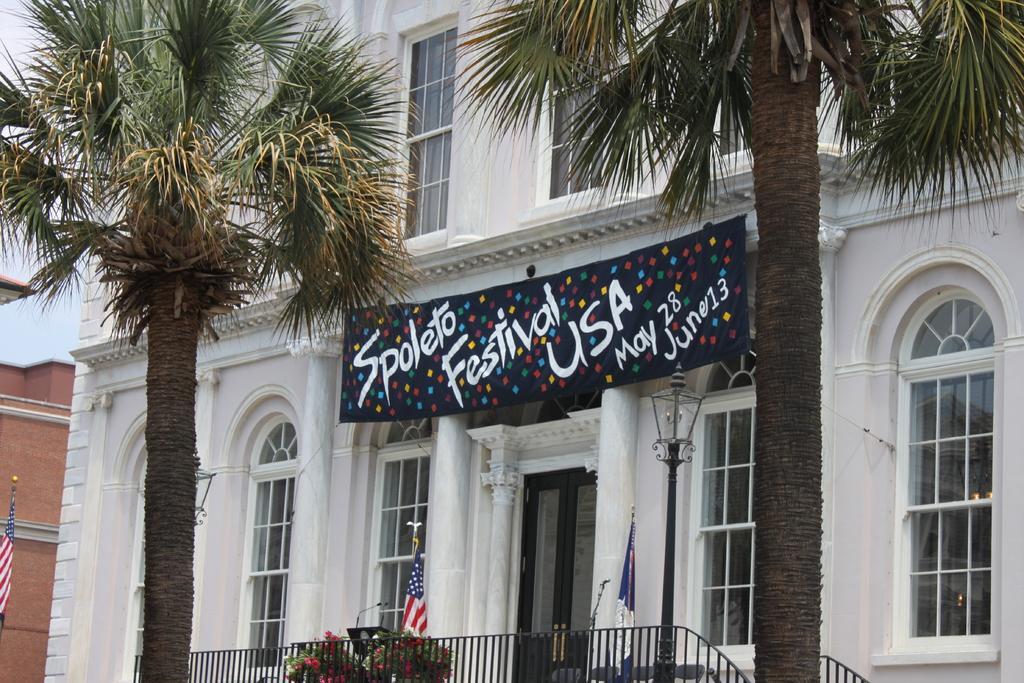Please provide a concise description of this image. At the bottom of the picture, we see the railing and the flowertots. Beside that, we see chairs and flags which are in white, red and blue color. On either side of the picture, we see two trees and a light pole. In the background, we see a building in white color. It has windows. In the middle of the picture, we see a banner in black color with some text written on it. On the left side, we see a flag in white, red and blue color. Behind that, we see a building which is made up of brown colored bricks. 